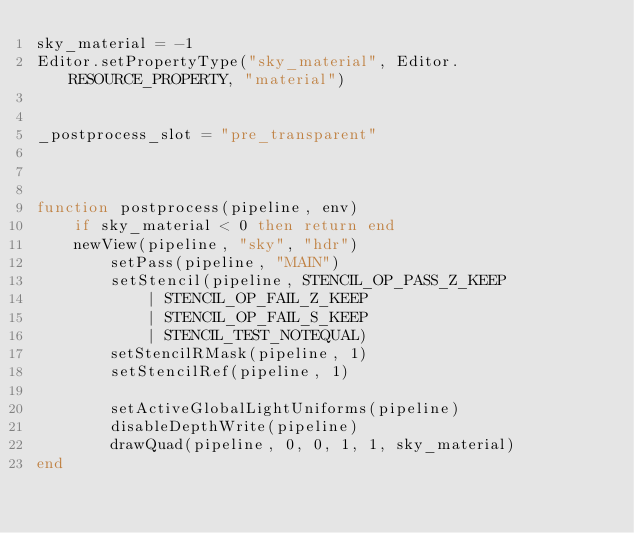<code> <loc_0><loc_0><loc_500><loc_500><_Lua_>sky_material = -1
Editor.setPropertyType("sky_material", Editor.RESOURCE_PROPERTY, "material")


_postprocess_slot = "pre_transparent"



function postprocess(pipeline, env)
	if sky_material < 0 then return end
	newView(pipeline, "sky", "hdr")
		setPass(pipeline, "MAIN")
		setStencil(pipeline, STENCIL_OP_PASS_Z_KEEP 
			| STENCIL_OP_FAIL_Z_KEEP 
			| STENCIL_OP_FAIL_S_KEEP 
			| STENCIL_TEST_NOTEQUAL)
		setStencilRMask(pipeline, 1)
		setStencilRef(pipeline, 1)

		setActiveGlobalLightUniforms(pipeline)
		disableDepthWrite(pipeline)
		drawQuad(pipeline, 0, 0, 1, 1, sky_material)
end</code> 